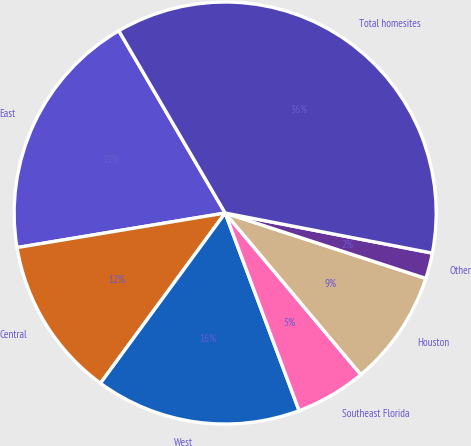Convert chart. <chart><loc_0><loc_0><loc_500><loc_500><pie_chart><fcel>East<fcel>Central<fcel>West<fcel>Southeast Florida<fcel>Houston<fcel>Other<fcel>Total homesites<nl><fcel>19.21%<fcel>12.32%<fcel>15.76%<fcel>5.42%<fcel>8.87%<fcel>1.97%<fcel>36.45%<nl></chart> 